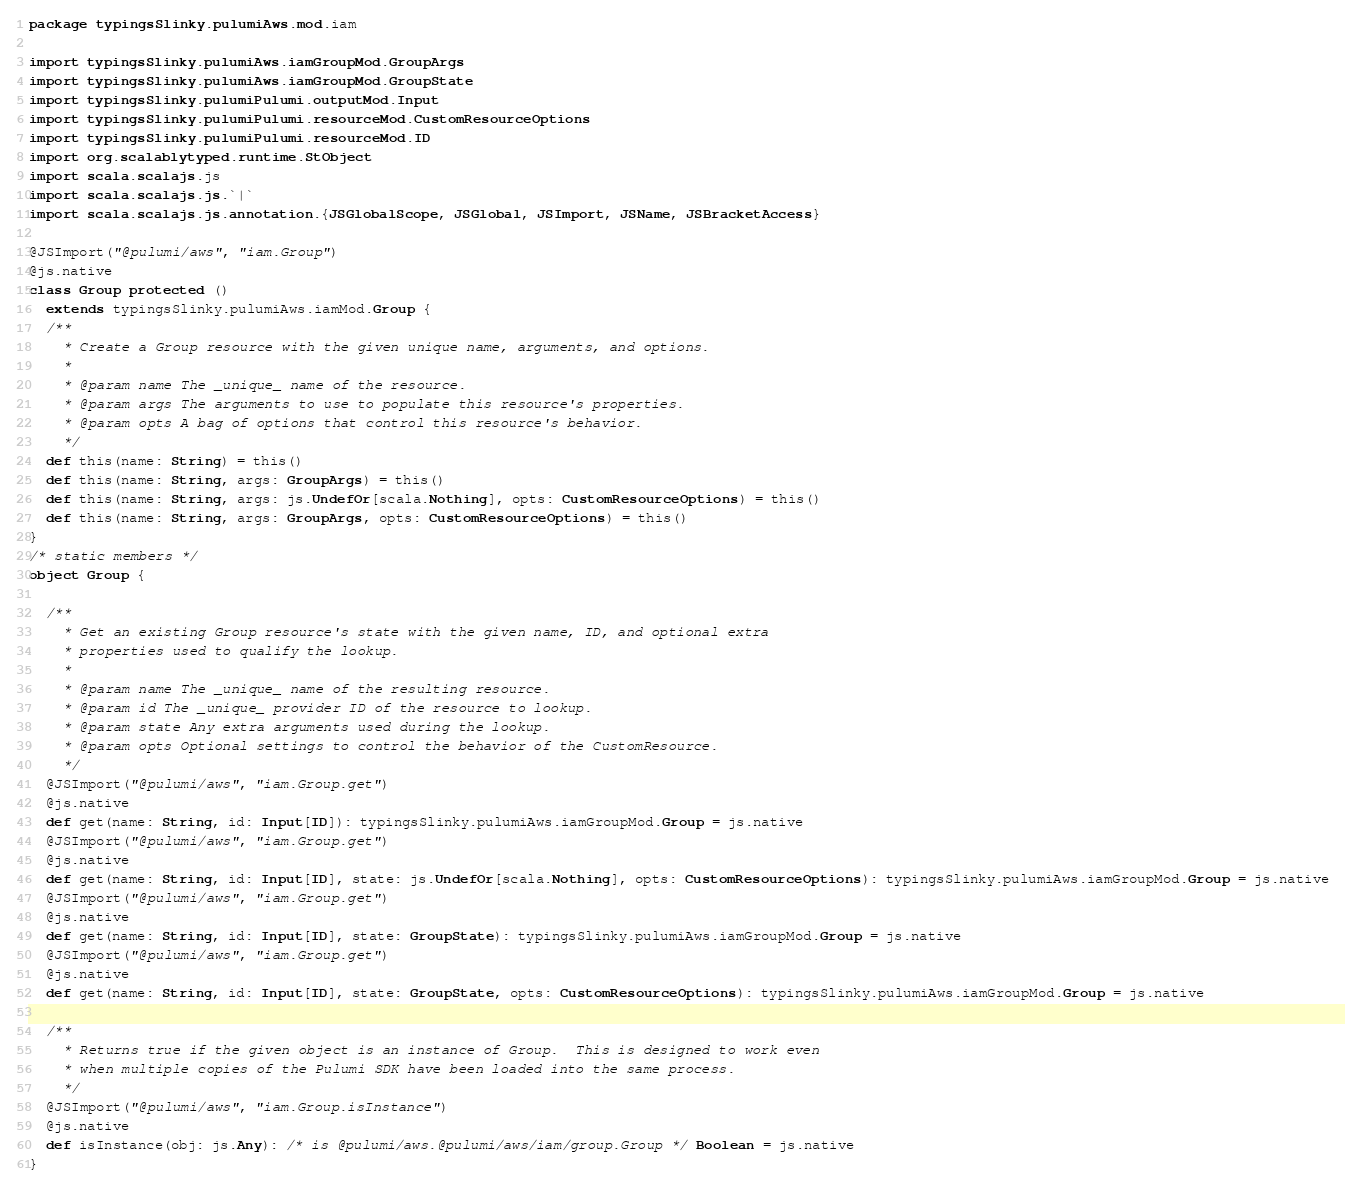<code> <loc_0><loc_0><loc_500><loc_500><_Scala_>package typingsSlinky.pulumiAws.mod.iam

import typingsSlinky.pulumiAws.iamGroupMod.GroupArgs
import typingsSlinky.pulumiAws.iamGroupMod.GroupState
import typingsSlinky.pulumiPulumi.outputMod.Input
import typingsSlinky.pulumiPulumi.resourceMod.CustomResourceOptions
import typingsSlinky.pulumiPulumi.resourceMod.ID
import org.scalablytyped.runtime.StObject
import scala.scalajs.js
import scala.scalajs.js.`|`
import scala.scalajs.js.annotation.{JSGlobalScope, JSGlobal, JSImport, JSName, JSBracketAccess}

@JSImport("@pulumi/aws", "iam.Group")
@js.native
class Group protected ()
  extends typingsSlinky.pulumiAws.iamMod.Group {
  /**
    * Create a Group resource with the given unique name, arguments, and options.
    *
    * @param name The _unique_ name of the resource.
    * @param args The arguments to use to populate this resource's properties.
    * @param opts A bag of options that control this resource's behavior.
    */
  def this(name: String) = this()
  def this(name: String, args: GroupArgs) = this()
  def this(name: String, args: js.UndefOr[scala.Nothing], opts: CustomResourceOptions) = this()
  def this(name: String, args: GroupArgs, opts: CustomResourceOptions) = this()
}
/* static members */
object Group {
  
  /**
    * Get an existing Group resource's state with the given name, ID, and optional extra
    * properties used to qualify the lookup.
    *
    * @param name The _unique_ name of the resulting resource.
    * @param id The _unique_ provider ID of the resource to lookup.
    * @param state Any extra arguments used during the lookup.
    * @param opts Optional settings to control the behavior of the CustomResource.
    */
  @JSImport("@pulumi/aws", "iam.Group.get")
  @js.native
  def get(name: String, id: Input[ID]): typingsSlinky.pulumiAws.iamGroupMod.Group = js.native
  @JSImport("@pulumi/aws", "iam.Group.get")
  @js.native
  def get(name: String, id: Input[ID], state: js.UndefOr[scala.Nothing], opts: CustomResourceOptions): typingsSlinky.pulumiAws.iamGroupMod.Group = js.native
  @JSImport("@pulumi/aws", "iam.Group.get")
  @js.native
  def get(name: String, id: Input[ID], state: GroupState): typingsSlinky.pulumiAws.iamGroupMod.Group = js.native
  @JSImport("@pulumi/aws", "iam.Group.get")
  @js.native
  def get(name: String, id: Input[ID], state: GroupState, opts: CustomResourceOptions): typingsSlinky.pulumiAws.iamGroupMod.Group = js.native
  
  /**
    * Returns true if the given object is an instance of Group.  This is designed to work even
    * when multiple copies of the Pulumi SDK have been loaded into the same process.
    */
  @JSImport("@pulumi/aws", "iam.Group.isInstance")
  @js.native
  def isInstance(obj: js.Any): /* is @pulumi/aws.@pulumi/aws/iam/group.Group */ Boolean = js.native
}
</code> 